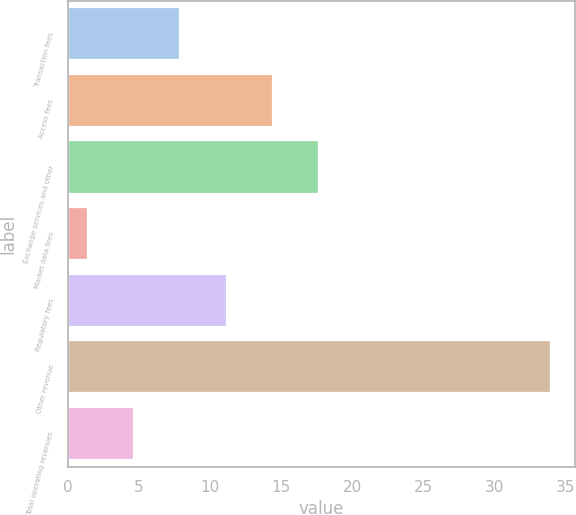<chart> <loc_0><loc_0><loc_500><loc_500><bar_chart><fcel>Transaction fees<fcel>Access fees<fcel>Exchange services and other<fcel>Market data fees<fcel>Regulatory fees<fcel>Other revenue<fcel>Total operating revenues<nl><fcel>7.92<fcel>14.44<fcel>17.7<fcel>1.4<fcel>11.18<fcel>34<fcel>4.66<nl></chart> 